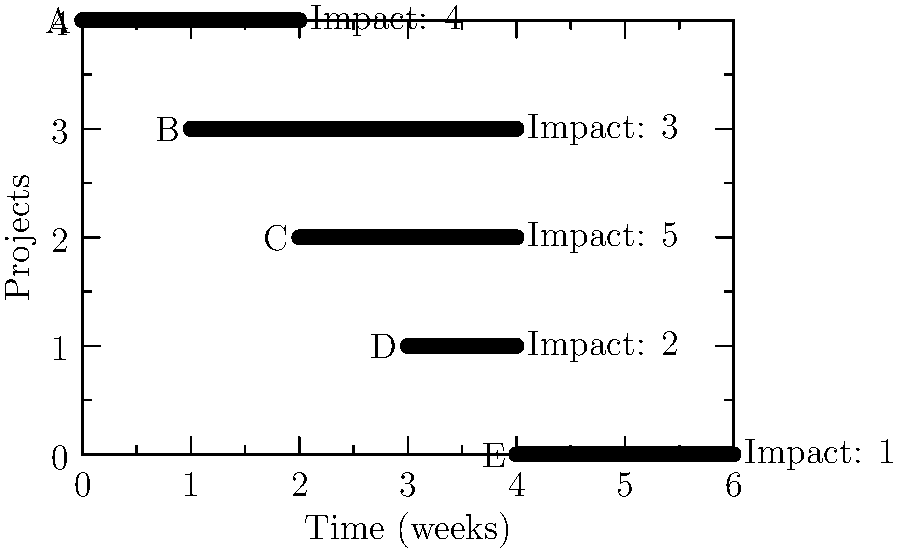Given the Gantt chart showing algorithm improvement projects with their durations and business impact scores, which project should be prioritized first to maximize immediate business value, and what is its total impact score when considering both duration and business impact? To solve this problem, we need to follow these steps:

1. Identify the projects that can start immediately (week 0):
   - Project A is the only project starting at week 0.

2. For projects that can start immediately, calculate their total impact score:
   - Total impact score = Business impact * Duration
   - For Project A: $4 * 2 = 8$

3. Compare the total impact scores of projects that can start immediately:
   - Since there's only one project (A) that can start immediately, it is automatically the highest priority.

4. Verify that no other project has a higher total impact score:
   - Project B: $3 * 3 = 9$
   - Project C: $5 * 2 = 10$
   - Project D: $2 * 1 = 2$
   - Project E: $1 * 2 = 2$

   Although Project C has a higher total impact score, it cannot start immediately, so it's not the correct choice for immediate prioritization.

5. Conclude that Project A should be prioritized first to maximize immediate business value.

6. Report the total impact score for Project A: 8.
Answer: Project A, with a total impact score of 8. 